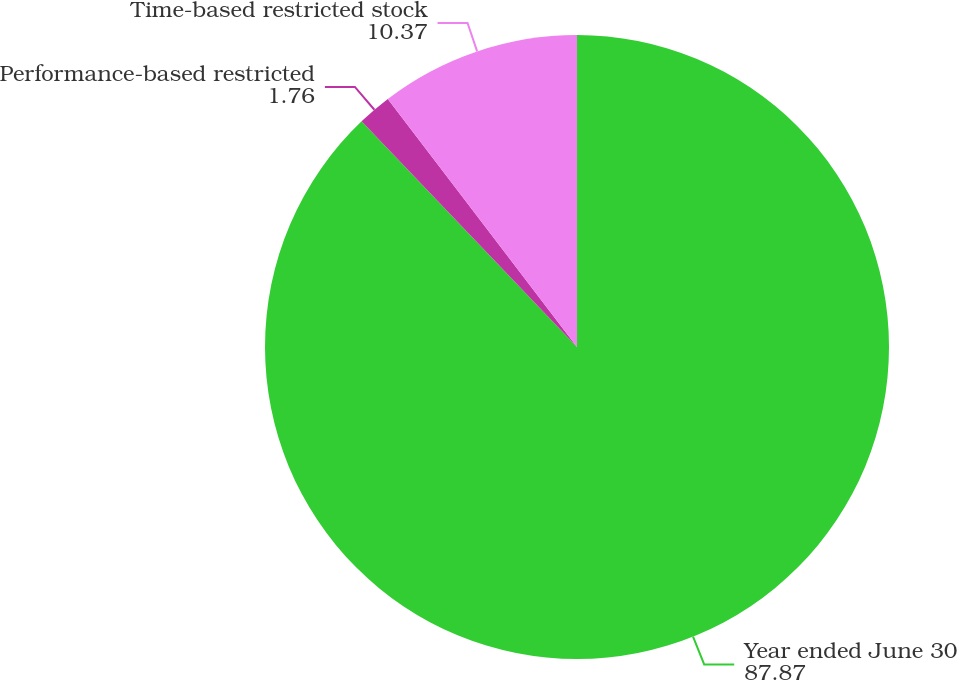Convert chart. <chart><loc_0><loc_0><loc_500><loc_500><pie_chart><fcel>Year ended June 30<fcel>Performance-based restricted<fcel>Time-based restricted stock<nl><fcel>87.87%<fcel>1.76%<fcel>10.37%<nl></chart> 